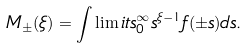Convert formula to latex. <formula><loc_0><loc_0><loc_500><loc_500>M _ { \pm } ( \xi ) = \int \lim i t s _ { 0 } ^ { \infty } s ^ { \xi - 1 } f ( \pm s ) d s .</formula> 